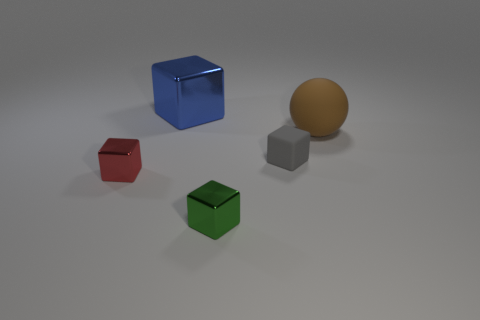Subtract all green blocks. How many blocks are left? 3 Subtract all blue shiny cubes. How many cubes are left? 3 Subtract all purple cubes. Subtract all green cylinders. How many cubes are left? 4 Add 5 tiny objects. How many objects exist? 10 Subtract all blocks. How many objects are left? 1 Subtract all big brown rubber spheres. Subtract all tiny things. How many objects are left? 1 Add 2 balls. How many balls are left? 3 Add 1 small blue matte objects. How many small blue matte objects exist? 1 Subtract 1 green cubes. How many objects are left? 4 